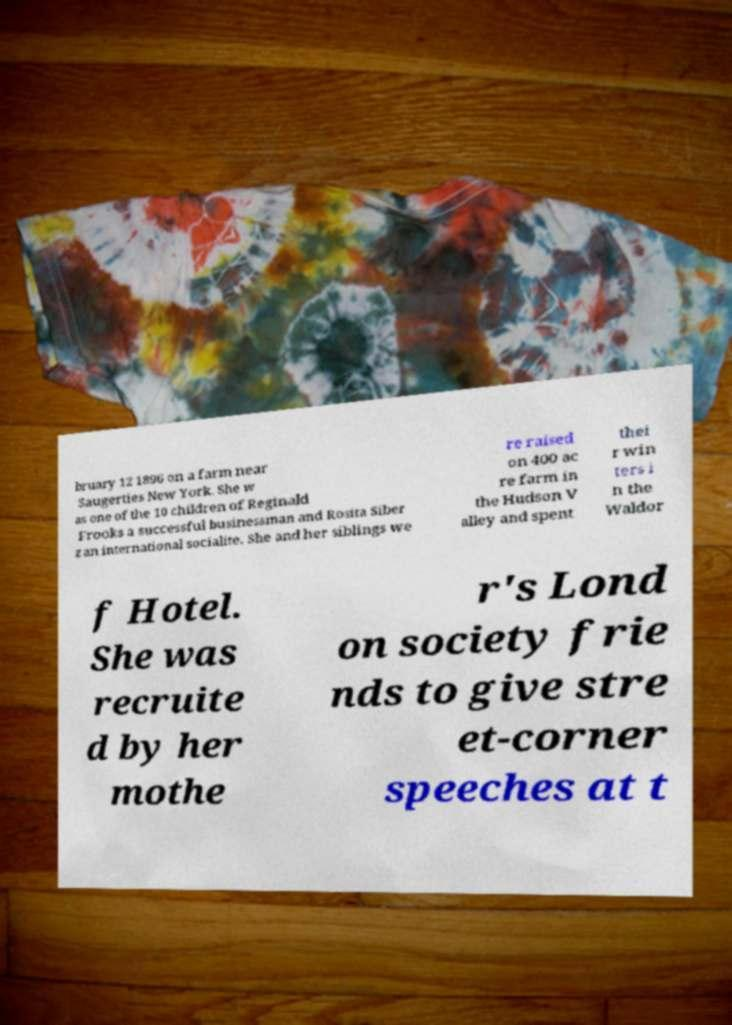I need the written content from this picture converted into text. Can you do that? bruary 12 1896 on a farm near Saugerties New York. She w as one of the 10 children of Reginald Frooks a successful businessman and Rosita Siber z an international socialite. She and her siblings we re raised on 400 ac re farm in the Hudson V alley and spent thei r win ters i n the Waldor f Hotel. She was recruite d by her mothe r's Lond on society frie nds to give stre et-corner speeches at t 